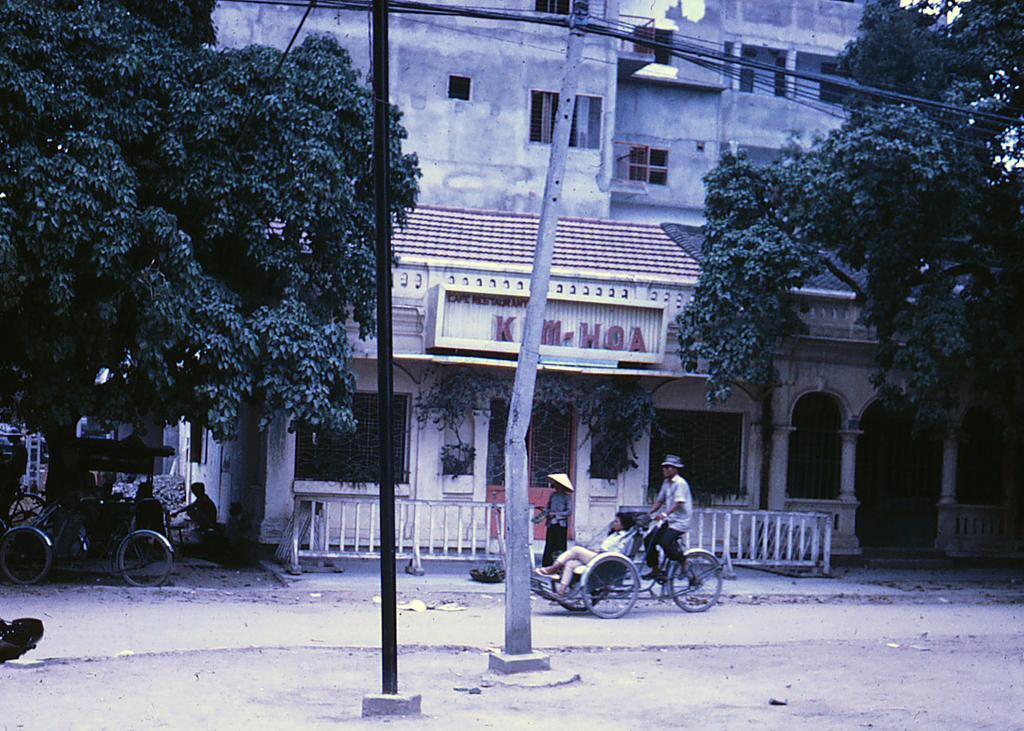How would you summarize this image in a sentence or two? In this image we can see trees, buildings, poles, name boards, grills, persons, road and carts. 